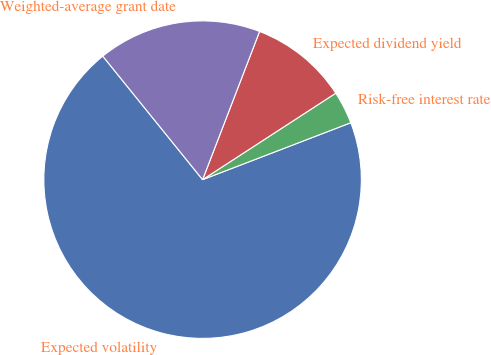<chart> <loc_0><loc_0><loc_500><loc_500><pie_chart><fcel>Expected volatility<fcel>Risk-free interest rate<fcel>Expected dividend yield<fcel>Weighted-average grant date<nl><fcel>70.02%<fcel>3.33%<fcel>9.99%<fcel>16.66%<nl></chart> 